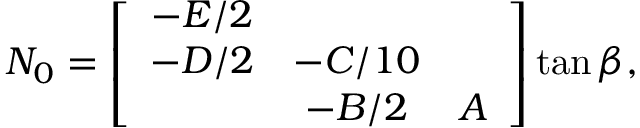Convert formula to latex. <formula><loc_0><loc_0><loc_500><loc_500>N _ { 0 } = \left [ \begin{array} { c c c } { - E / 2 } \\ { - D / 2 } & { - C / 1 0 } & { - B / 2 } & { A } \end{array} \right ] \tan \beta ,</formula> 